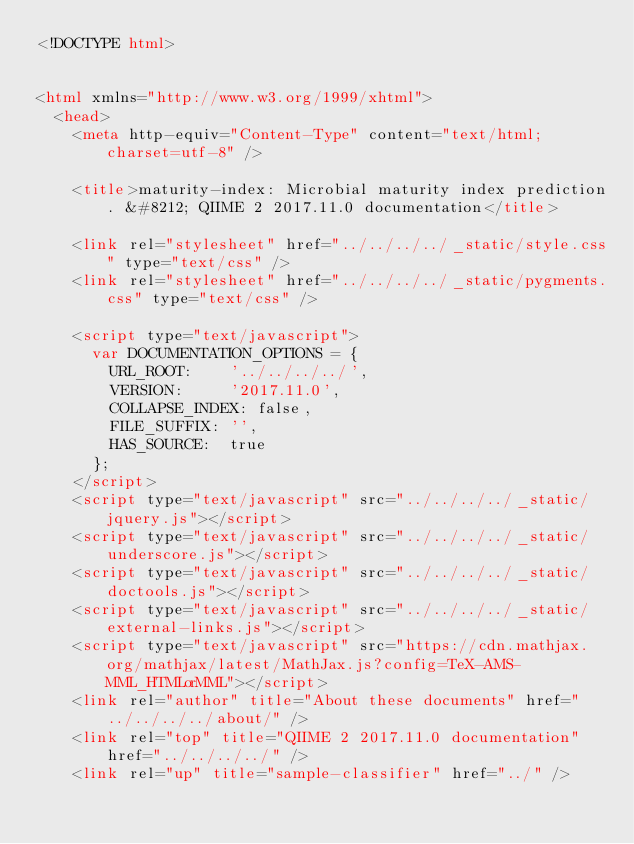<code> <loc_0><loc_0><loc_500><loc_500><_HTML_><!DOCTYPE html>


<html xmlns="http://www.w3.org/1999/xhtml">
  <head>
    <meta http-equiv="Content-Type" content="text/html; charset=utf-8" />
    
    <title>maturity-index: Microbial maturity index prediction. &#8212; QIIME 2 2017.11.0 documentation</title>
    
    <link rel="stylesheet" href="../../../../_static/style.css" type="text/css" />
    <link rel="stylesheet" href="../../../../_static/pygments.css" type="text/css" />
    
    <script type="text/javascript">
      var DOCUMENTATION_OPTIONS = {
        URL_ROOT:    '../../../../',
        VERSION:     '2017.11.0',
        COLLAPSE_INDEX: false,
        FILE_SUFFIX: '',
        HAS_SOURCE:  true
      };
    </script>
    <script type="text/javascript" src="../../../../_static/jquery.js"></script>
    <script type="text/javascript" src="../../../../_static/underscore.js"></script>
    <script type="text/javascript" src="../../../../_static/doctools.js"></script>
    <script type="text/javascript" src="../../../../_static/external-links.js"></script>
    <script type="text/javascript" src="https://cdn.mathjax.org/mathjax/latest/MathJax.js?config=TeX-AMS-MML_HTMLorMML"></script>
    <link rel="author" title="About these documents" href="../../../../about/" />
    <link rel="top" title="QIIME 2 2017.11.0 documentation" href="../../../../" />
    <link rel="up" title="sample-classifier" href="../" /></code> 